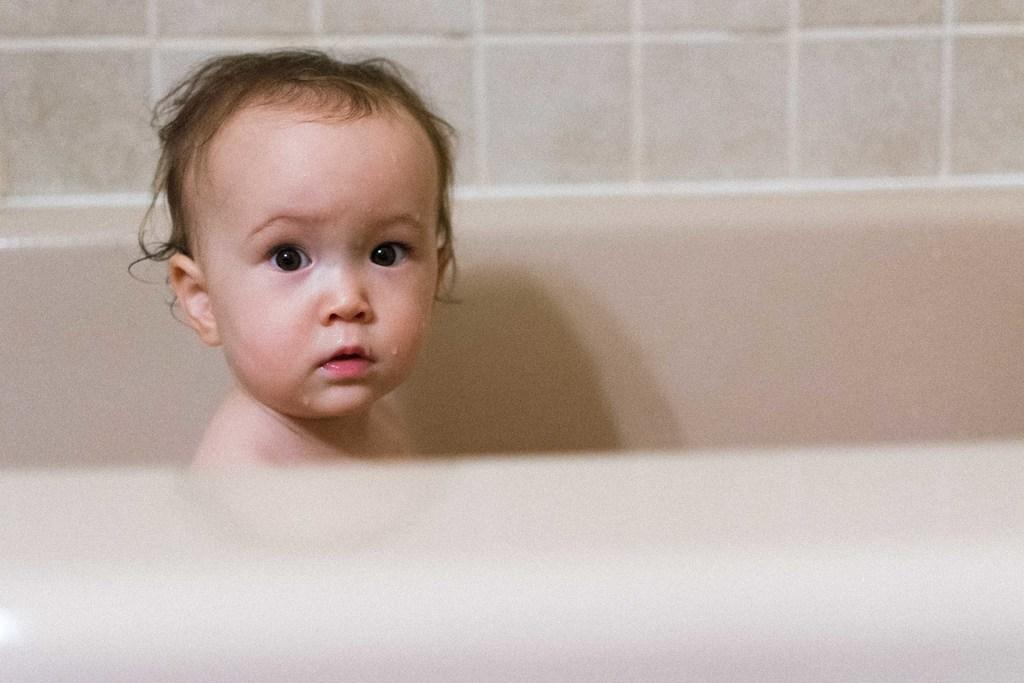What is the main subject of the image? There is a baby in the center of the image. What can be seen in the background of the image? There is a wall in the background of the image. How many snails can be seen looking at the baby in the image? There are no snails present in the image, and therefore no such activity can be observed. 